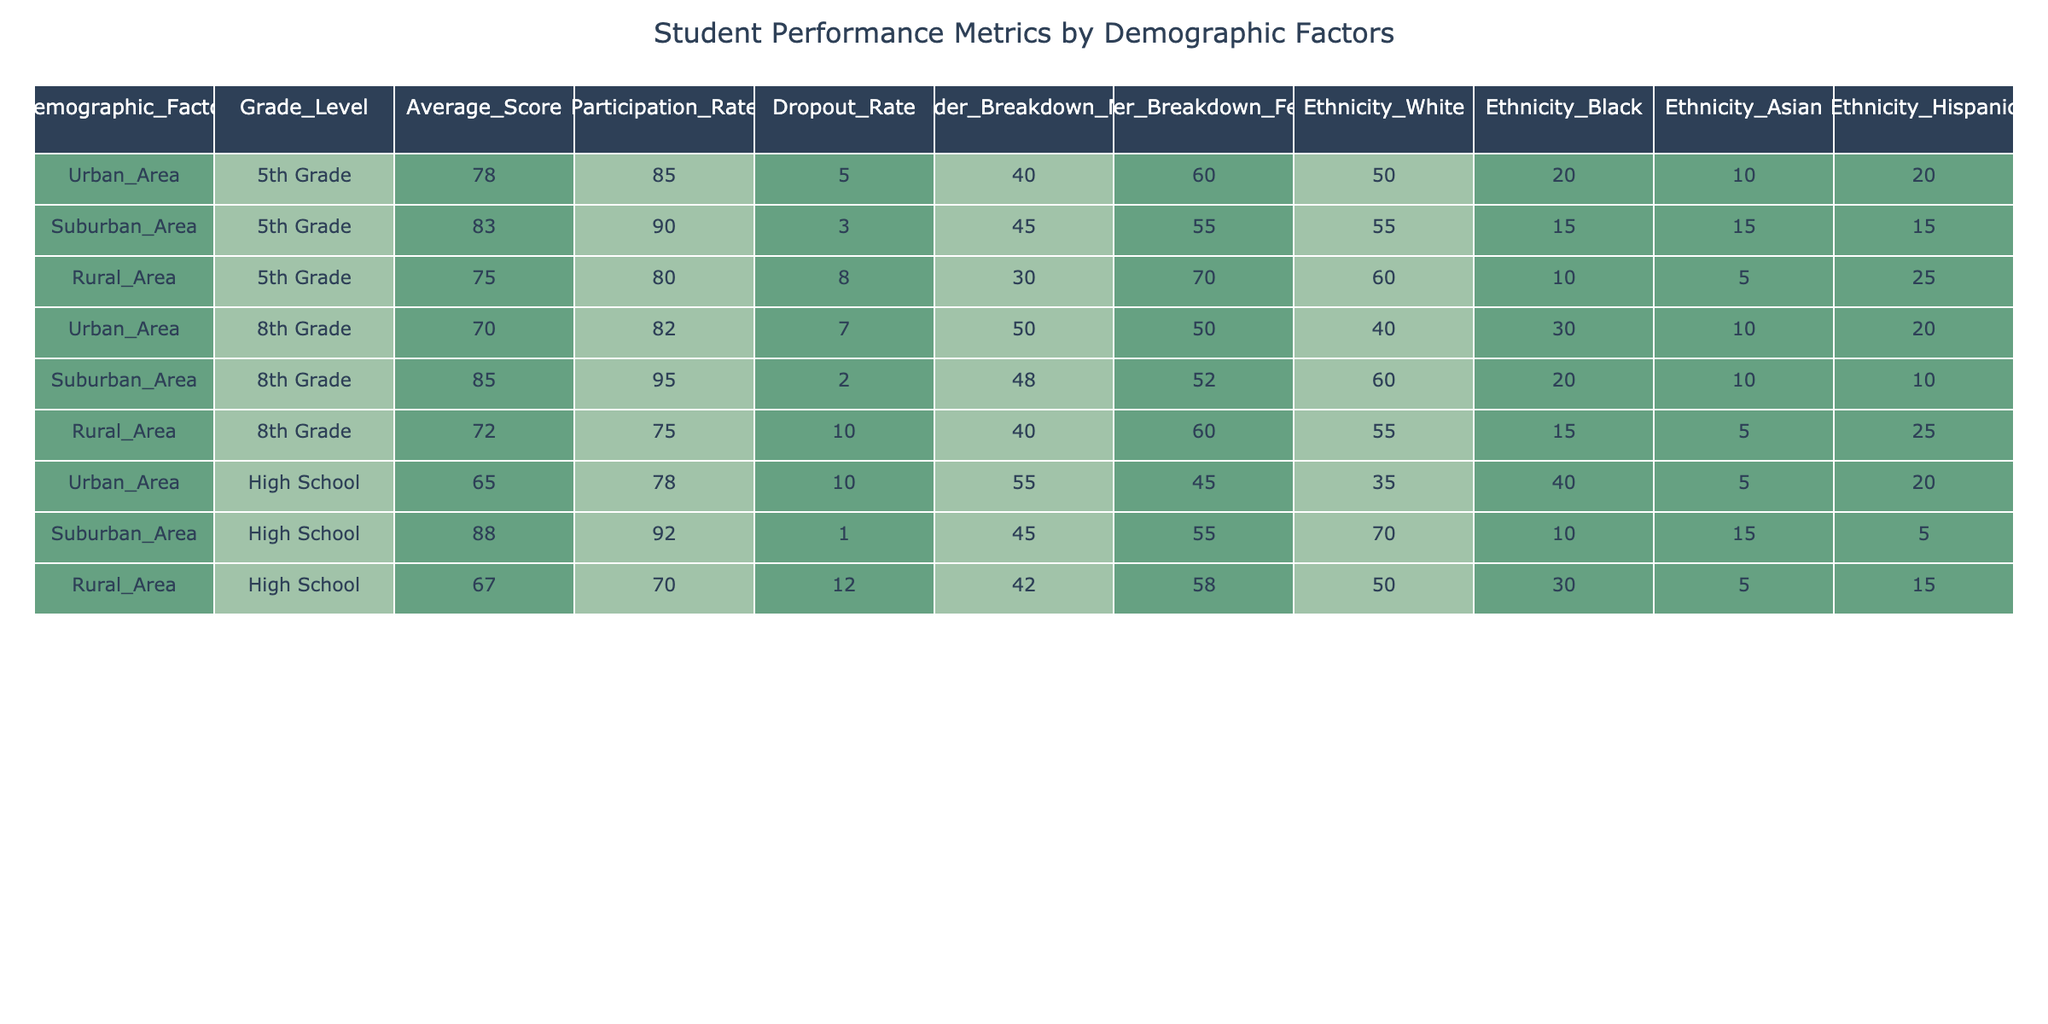What is the average score for 5th-grade students in Urban Areas? The average score for 5th-grade students in Urban Areas is listed in the table under the "Average_Score" column for the "Urban_Area" demographic and the "5th Grade" grade level, which is 78.
Answer: 78 What is the participation rate for High School students in Suburban Areas? Referring to the table, for the "Suburban_Area" demographic and "High School" grade level, the participation rate is found in the "Participation_Rate" column, which states it is 92.
Answer: 92 Do more male or female students participate in 8th grade in the Urban Area? In the Urban Area for 8th grade, the gender breakdown shows 50 males and 50 females, indicating equal participation rates among both genders.
Answer: No What is the dropout rate for Rural Area High School students? The dropout rate for students in the High School level from the Rural Area can be taken from the table, which shows a dropout rate of 12.
Answer: 12 Which demographic has the highest average score among 8th graders? Comparing the average scores for 8th graders from each demographic (Urban: 70, Suburban: 85, Rural: 72), the Suburban Area has the highest average score of 85.
Answer: Suburban Area Calculate the difference in participation rates between 5th graders in Suburban and Rural Areas. The participation rate for 5th graders in Suburban Areas is 90, while in Rural Areas it is 80. The difference is calculated as 90 - 80 = 10.
Answer: 10 Is the average score higher for High School students in Urban Areas compared to Rural Areas? In the table, the average score for Urban Area High School students is 65, while for Rural Area High School students it is 67. Thus, the average score is not higher in Urban Areas.
Answer: No What percentage of the 5th-grade students in the Urban Area are Black? In the Urban Area for 5th graders, 20% of the demographic is listed as ethnicity Black according to the "Ethnicity_Black" column in the table.
Answer: 20 Calculate the average participation rate across all demographics for 8th grade students. The participation rates for 8th graders across demographics are: Urban (82), Suburban (95), and Rural (75). To find the average, sum them: 82 + 95 + 75 = 252, then divide by 3, resulting in an average participation rate of 84.
Answer: 84 